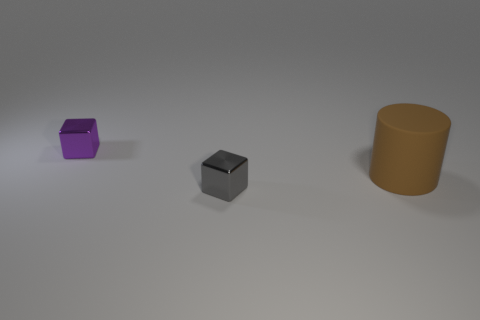Are there any other things that are the same material as the brown object?
Provide a succinct answer. No. How many things are both left of the brown object and behind the tiny gray thing?
Give a very brief answer. 1. There is a tiny purple object that is the same shape as the tiny gray object; what material is it?
Offer a terse response. Metal. Are there an equal number of brown matte things that are on the left side of the tiny purple object and large brown rubber objects on the right side of the brown cylinder?
Provide a short and direct response. Yes. Is the material of the purple block the same as the small gray thing?
Provide a short and direct response. Yes. What number of brown objects are either matte cubes or large matte objects?
Ensure brevity in your answer.  1. What number of large brown matte things are the same shape as the tiny purple thing?
Offer a very short reply. 0. What material is the large object?
Make the answer very short. Rubber. Is the number of matte things that are on the right side of the purple thing the same as the number of cyan cylinders?
Make the answer very short. No. What is the shape of the purple thing that is the same size as the gray thing?
Ensure brevity in your answer.  Cube. 